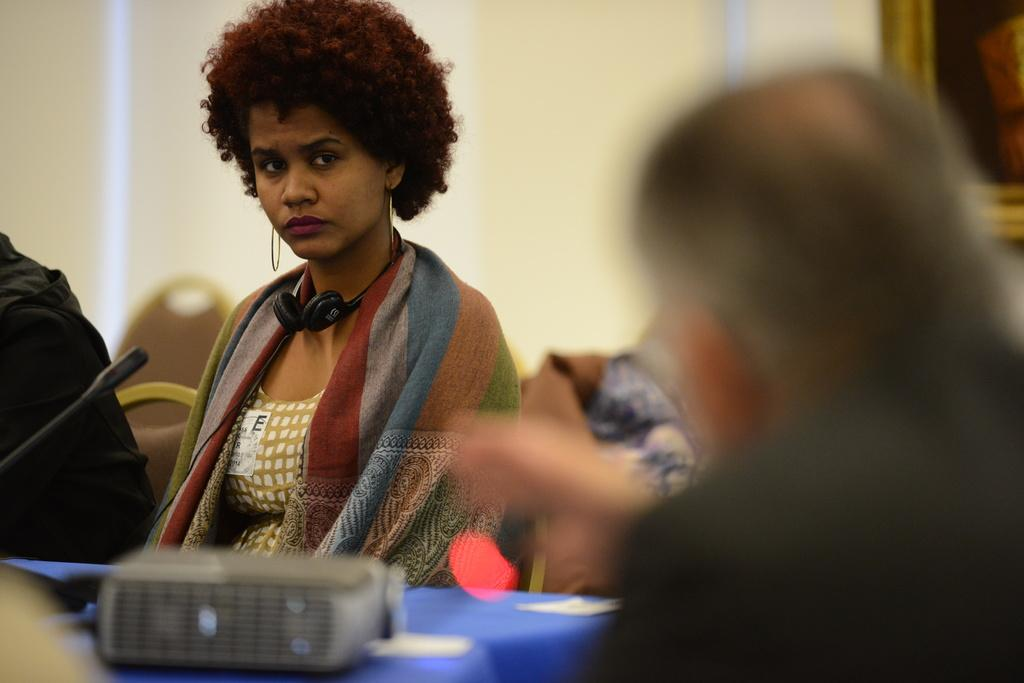How many people are in the image? There are people in the image, but the exact number is not specified. What object is used for amplifying sound in the image? There is a microphone in the image. What type of device is present in the image? There is a device in the image, but its specific purpose is not mentioned. What can be found on the table in the image? There are objects on the table in the image. What type of furniture is present in the image? There are chairs in the image. What is hanging on the wall in the background of the image? There is a frame on the wall in the background of the image. What type of canvas is being painted in the image? There is no canvas or painting activity present in the image. 